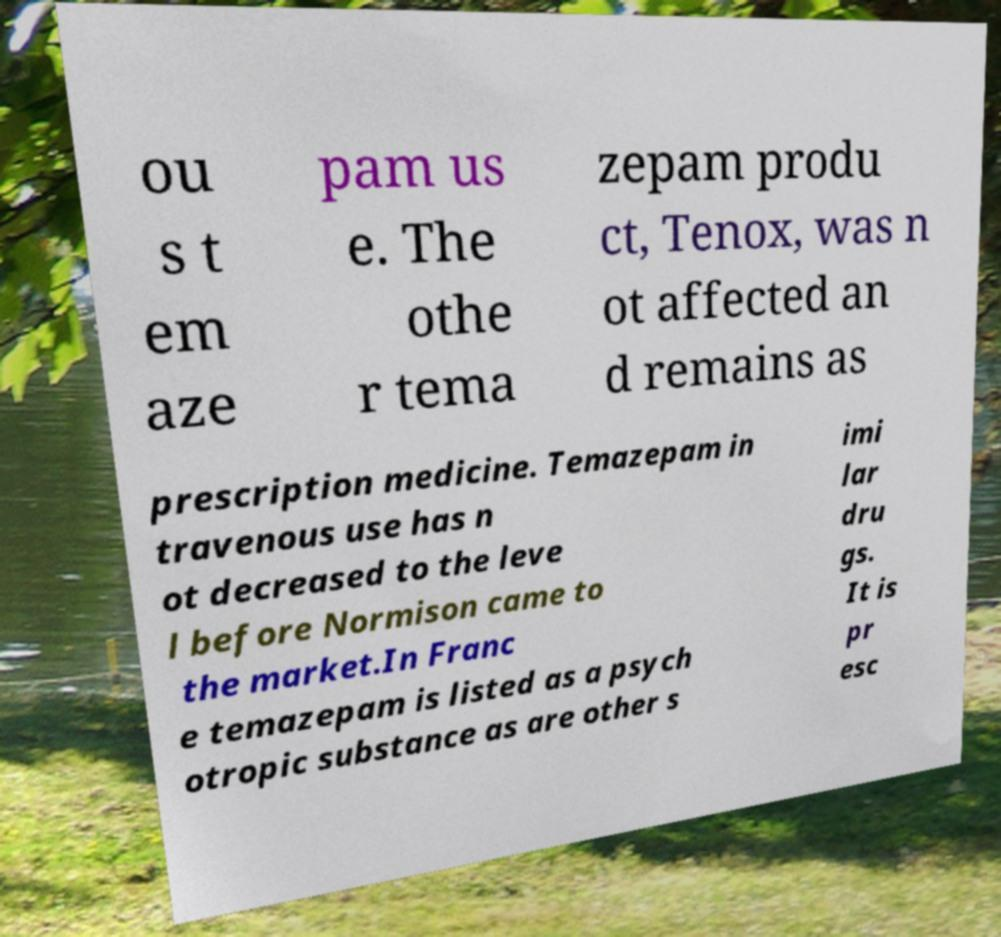Can you read and provide the text displayed in the image?This photo seems to have some interesting text. Can you extract and type it out for me? ou s t em aze pam us e. The othe r tema zepam produ ct, Tenox, was n ot affected an d remains as prescription medicine. Temazepam in travenous use has n ot decreased to the leve l before Normison came to the market.In Franc e temazepam is listed as a psych otropic substance as are other s imi lar dru gs. It is pr esc 